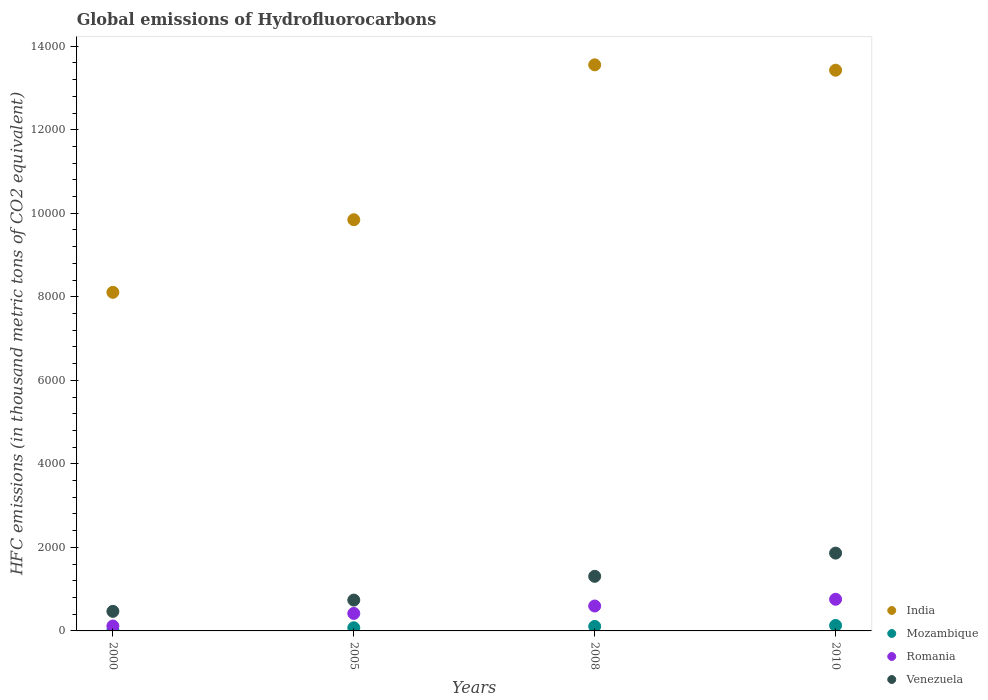Is the number of dotlines equal to the number of legend labels?
Make the answer very short. Yes. What is the global emissions of Hydrofluorocarbons in Romania in 2005?
Make the answer very short. 418.8. Across all years, what is the maximum global emissions of Hydrofluorocarbons in Venezuela?
Your answer should be compact. 1863. In which year was the global emissions of Hydrofluorocarbons in Romania minimum?
Provide a succinct answer. 2000. What is the total global emissions of Hydrofluorocarbons in Venezuela in the graph?
Provide a short and direct response. 4377. What is the difference between the global emissions of Hydrofluorocarbons in India in 2000 and that in 2008?
Give a very brief answer. -5446.5. What is the average global emissions of Hydrofluorocarbons in Romania per year?
Give a very brief answer. 472.85. In the year 2008, what is the difference between the global emissions of Hydrofluorocarbons in Venezuela and global emissions of Hydrofluorocarbons in Mozambique?
Make the answer very short. 1199.2. In how many years, is the global emissions of Hydrofluorocarbons in Venezuela greater than 2000 thousand metric tons?
Your answer should be very brief. 0. What is the ratio of the global emissions of Hydrofluorocarbons in Venezuela in 2005 to that in 2008?
Make the answer very short. 0.56. What is the difference between the highest and the second highest global emissions of Hydrofluorocarbons in India?
Provide a short and direct response. 128.7. What is the difference between the highest and the lowest global emissions of Hydrofluorocarbons in Venezuela?
Your response must be concise. 1394.5. In how many years, is the global emissions of Hydrofluorocarbons in Mozambique greater than the average global emissions of Hydrofluorocarbons in Mozambique taken over all years?
Give a very brief answer. 2. Is the sum of the global emissions of Hydrofluorocarbons in Mozambique in 2005 and 2008 greater than the maximum global emissions of Hydrofluorocarbons in Venezuela across all years?
Keep it short and to the point. No. Is it the case that in every year, the sum of the global emissions of Hydrofluorocarbons in Mozambique and global emissions of Hydrofluorocarbons in India  is greater than the sum of global emissions of Hydrofluorocarbons in Romania and global emissions of Hydrofluorocarbons in Venezuela?
Offer a terse response. Yes. Is the global emissions of Hydrofluorocarbons in India strictly greater than the global emissions of Hydrofluorocarbons in Romania over the years?
Give a very brief answer. Yes. How many dotlines are there?
Offer a very short reply. 4. What is the difference between two consecutive major ticks on the Y-axis?
Your answer should be compact. 2000. Does the graph contain grids?
Your answer should be very brief. No. Where does the legend appear in the graph?
Offer a terse response. Bottom right. How are the legend labels stacked?
Your answer should be very brief. Vertical. What is the title of the graph?
Your answer should be very brief. Global emissions of Hydrofluorocarbons. What is the label or title of the Y-axis?
Provide a short and direct response. HFC emissions (in thousand metric tons of CO2 equivalent). What is the HFC emissions (in thousand metric tons of CO2 equivalent) in India in 2000?
Your answer should be very brief. 8107.2. What is the HFC emissions (in thousand metric tons of CO2 equivalent) in Romania in 2000?
Keep it short and to the point. 118.2. What is the HFC emissions (in thousand metric tons of CO2 equivalent) of Venezuela in 2000?
Give a very brief answer. 468.5. What is the HFC emissions (in thousand metric tons of CO2 equivalent) in India in 2005?
Provide a succinct answer. 9845.2. What is the HFC emissions (in thousand metric tons of CO2 equivalent) of Mozambique in 2005?
Offer a terse response. 75.2. What is the HFC emissions (in thousand metric tons of CO2 equivalent) in Romania in 2005?
Offer a terse response. 418.8. What is the HFC emissions (in thousand metric tons of CO2 equivalent) in Venezuela in 2005?
Provide a succinct answer. 738.4. What is the HFC emissions (in thousand metric tons of CO2 equivalent) in India in 2008?
Keep it short and to the point. 1.36e+04. What is the HFC emissions (in thousand metric tons of CO2 equivalent) in Mozambique in 2008?
Your answer should be compact. 107.9. What is the HFC emissions (in thousand metric tons of CO2 equivalent) of Romania in 2008?
Provide a short and direct response. 596.4. What is the HFC emissions (in thousand metric tons of CO2 equivalent) in Venezuela in 2008?
Keep it short and to the point. 1307.1. What is the HFC emissions (in thousand metric tons of CO2 equivalent) of India in 2010?
Your response must be concise. 1.34e+04. What is the HFC emissions (in thousand metric tons of CO2 equivalent) in Mozambique in 2010?
Keep it short and to the point. 131. What is the HFC emissions (in thousand metric tons of CO2 equivalent) in Romania in 2010?
Offer a terse response. 758. What is the HFC emissions (in thousand metric tons of CO2 equivalent) of Venezuela in 2010?
Make the answer very short. 1863. Across all years, what is the maximum HFC emissions (in thousand metric tons of CO2 equivalent) of India?
Your response must be concise. 1.36e+04. Across all years, what is the maximum HFC emissions (in thousand metric tons of CO2 equivalent) in Mozambique?
Give a very brief answer. 131. Across all years, what is the maximum HFC emissions (in thousand metric tons of CO2 equivalent) in Romania?
Your response must be concise. 758. Across all years, what is the maximum HFC emissions (in thousand metric tons of CO2 equivalent) in Venezuela?
Make the answer very short. 1863. Across all years, what is the minimum HFC emissions (in thousand metric tons of CO2 equivalent) of India?
Keep it short and to the point. 8107.2. Across all years, what is the minimum HFC emissions (in thousand metric tons of CO2 equivalent) of Mozambique?
Offer a very short reply. 18.8. Across all years, what is the minimum HFC emissions (in thousand metric tons of CO2 equivalent) in Romania?
Offer a terse response. 118.2. Across all years, what is the minimum HFC emissions (in thousand metric tons of CO2 equivalent) of Venezuela?
Provide a short and direct response. 468.5. What is the total HFC emissions (in thousand metric tons of CO2 equivalent) in India in the graph?
Offer a terse response. 4.49e+04. What is the total HFC emissions (in thousand metric tons of CO2 equivalent) of Mozambique in the graph?
Offer a terse response. 332.9. What is the total HFC emissions (in thousand metric tons of CO2 equivalent) of Romania in the graph?
Your answer should be very brief. 1891.4. What is the total HFC emissions (in thousand metric tons of CO2 equivalent) of Venezuela in the graph?
Provide a short and direct response. 4377. What is the difference between the HFC emissions (in thousand metric tons of CO2 equivalent) in India in 2000 and that in 2005?
Provide a short and direct response. -1738. What is the difference between the HFC emissions (in thousand metric tons of CO2 equivalent) of Mozambique in 2000 and that in 2005?
Provide a succinct answer. -56.4. What is the difference between the HFC emissions (in thousand metric tons of CO2 equivalent) in Romania in 2000 and that in 2005?
Provide a succinct answer. -300.6. What is the difference between the HFC emissions (in thousand metric tons of CO2 equivalent) in Venezuela in 2000 and that in 2005?
Your response must be concise. -269.9. What is the difference between the HFC emissions (in thousand metric tons of CO2 equivalent) in India in 2000 and that in 2008?
Ensure brevity in your answer.  -5446.5. What is the difference between the HFC emissions (in thousand metric tons of CO2 equivalent) in Mozambique in 2000 and that in 2008?
Make the answer very short. -89.1. What is the difference between the HFC emissions (in thousand metric tons of CO2 equivalent) of Romania in 2000 and that in 2008?
Offer a very short reply. -478.2. What is the difference between the HFC emissions (in thousand metric tons of CO2 equivalent) in Venezuela in 2000 and that in 2008?
Keep it short and to the point. -838.6. What is the difference between the HFC emissions (in thousand metric tons of CO2 equivalent) of India in 2000 and that in 2010?
Your answer should be very brief. -5317.8. What is the difference between the HFC emissions (in thousand metric tons of CO2 equivalent) of Mozambique in 2000 and that in 2010?
Provide a short and direct response. -112.2. What is the difference between the HFC emissions (in thousand metric tons of CO2 equivalent) in Romania in 2000 and that in 2010?
Offer a very short reply. -639.8. What is the difference between the HFC emissions (in thousand metric tons of CO2 equivalent) of Venezuela in 2000 and that in 2010?
Your answer should be very brief. -1394.5. What is the difference between the HFC emissions (in thousand metric tons of CO2 equivalent) in India in 2005 and that in 2008?
Your answer should be compact. -3708.5. What is the difference between the HFC emissions (in thousand metric tons of CO2 equivalent) in Mozambique in 2005 and that in 2008?
Provide a succinct answer. -32.7. What is the difference between the HFC emissions (in thousand metric tons of CO2 equivalent) of Romania in 2005 and that in 2008?
Provide a short and direct response. -177.6. What is the difference between the HFC emissions (in thousand metric tons of CO2 equivalent) in Venezuela in 2005 and that in 2008?
Give a very brief answer. -568.7. What is the difference between the HFC emissions (in thousand metric tons of CO2 equivalent) in India in 2005 and that in 2010?
Offer a terse response. -3579.8. What is the difference between the HFC emissions (in thousand metric tons of CO2 equivalent) of Mozambique in 2005 and that in 2010?
Offer a very short reply. -55.8. What is the difference between the HFC emissions (in thousand metric tons of CO2 equivalent) of Romania in 2005 and that in 2010?
Make the answer very short. -339.2. What is the difference between the HFC emissions (in thousand metric tons of CO2 equivalent) in Venezuela in 2005 and that in 2010?
Give a very brief answer. -1124.6. What is the difference between the HFC emissions (in thousand metric tons of CO2 equivalent) in India in 2008 and that in 2010?
Your response must be concise. 128.7. What is the difference between the HFC emissions (in thousand metric tons of CO2 equivalent) in Mozambique in 2008 and that in 2010?
Provide a succinct answer. -23.1. What is the difference between the HFC emissions (in thousand metric tons of CO2 equivalent) in Romania in 2008 and that in 2010?
Your response must be concise. -161.6. What is the difference between the HFC emissions (in thousand metric tons of CO2 equivalent) of Venezuela in 2008 and that in 2010?
Your response must be concise. -555.9. What is the difference between the HFC emissions (in thousand metric tons of CO2 equivalent) in India in 2000 and the HFC emissions (in thousand metric tons of CO2 equivalent) in Mozambique in 2005?
Make the answer very short. 8032. What is the difference between the HFC emissions (in thousand metric tons of CO2 equivalent) in India in 2000 and the HFC emissions (in thousand metric tons of CO2 equivalent) in Romania in 2005?
Keep it short and to the point. 7688.4. What is the difference between the HFC emissions (in thousand metric tons of CO2 equivalent) in India in 2000 and the HFC emissions (in thousand metric tons of CO2 equivalent) in Venezuela in 2005?
Keep it short and to the point. 7368.8. What is the difference between the HFC emissions (in thousand metric tons of CO2 equivalent) in Mozambique in 2000 and the HFC emissions (in thousand metric tons of CO2 equivalent) in Romania in 2005?
Provide a short and direct response. -400. What is the difference between the HFC emissions (in thousand metric tons of CO2 equivalent) in Mozambique in 2000 and the HFC emissions (in thousand metric tons of CO2 equivalent) in Venezuela in 2005?
Make the answer very short. -719.6. What is the difference between the HFC emissions (in thousand metric tons of CO2 equivalent) in Romania in 2000 and the HFC emissions (in thousand metric tons of CO2 equivalent) in Venezuela in 2005?
Your response must be concise. -620.2. What is the difference between the HFC emissions (in thousand metric tons of CO2 equivalent) of India in 2000 and the HFC emissions (in thousand metric tons of CO2 equivalent) of Mozambique in 2008?
Provide a short and direct response. 7999.3. What is the difference between the HFC emissions (in thousand metric tons of CO2 equivalent) in India in 2000 and the HFC emissions (in thousand metric tons of CO2 equivalent) in Romania in 2008?
Your answer should be compact. 7510.8. What is the difference between the HFC emissions (in thousand metric tons of CO2 equivalent) of India in 2000 and the HFC emissions (in thousand metric tons of CO2 equivalent) of Venezuela in 2008?
Provide a short and direct response. 6800.1. What is the difference between the HFC emissions (in thousand metric tons of CO2 equivalent) in Mozambique in 2000 and the HFC emissions (in thousand metric tons of CO2 equivalent) in Romania in 2008?
Make the answer very short. -577.6. What is the difference between the HFC emissions (in thousand metric tons of CO2 equivalent) in Mozambique in 2000 and the HFC emissions (in thousand metric tons of CO2 equivalent) in Venezuela in 2008?
Provide a succinct answer. -1288.3. What is the difference between the HFC emissions (in thousand metric tons of CO2 equivalent) in Romania in 2000 and the HFC emissions (in thousand metric tons of CO2 equivalent) in Venezuela in 2008?
Your answer should be very brief. -1188.9. What is the difference between the HFC emissions (in thousand metric tons of CO2 equivalent) of India in 2000 and the HFC emissions (in thousand metric tons of CO2 equivalent) of Mozambique in 2010?
Keep it short and to the point. 7976.2. What is the difference between the HFC emissions (in thousand metric tons of CO2 equivalent) in India in 2000 and the HFC emissions (in thousand metric tons of CO2 equivalent) in Romania in 2010?
Offer a very short reply. 7349.2. What is the difference between the HFC emissions (in thousand metric tons of CO2 equivalent) in India in 2000 and the HFC emissions (in thousand metric tons of CO2 equivalent) in Venezuela in 2010?
Provide a succinct answer. 6244.2. What is the difference between the HFC emissions (in thousand metric tons of CO2 equivalent) of Mozambique in 2000 and the HFC emissions (in thousand metric tons of CO2 equivalent) of Romania in 2010?
Provide a succinct answer. -739.2. What is the difference between the HFC emissions (in thousand metric tons of CO2 equivalent) of Mozambique in 2000 and the HFC emissions (in thousand metric tons of CO2 equivalent) of Venezuela in 2010?
Make the answer very short. -1844.2. What is the difference between the HFC emissions (in thousand metric tons of CO2 equivalent) of Romania in 2000 and the HFC emissions (in thousand metric tons of CO2 equivalent) of Venezuela in 2010?
Provide a succinct answer. -1744.8. What is the difference between the HFC emissions (in thousand metric tons of CO2 equivalent) in India in 2005 and the HFC emissions (in thousand metric tons of CO2 equivalent) in Mozambique in 2008?
Provide a succinct answer. 9737.3. What is the difference between the HFC emissions (in thousand metric tons of CO2 equivalent) of India in 2005 and the HFC emissions (in thousand metric tons of CO2 equivalent) of Romania in 2008?
Give a very brief answer. 9248.8. What is the difference between the HFC emissions (in thousand metric tons of CO2 equivalent) in India in 2005 and the HFC emissions (in thousand metric tons of CO2 equivalent) in Venezuela in 2008?
Offer a terse response. 8538.1. What is the difference between the HFC emissions (in thousand metric tons of CO2 equivalent) of Mozambique in 2005 and the HFC emissions (in thousand metric tons of CO2 equivalent) of Romania in 2008?
Your answer should be very brief. -521.2. What is the difference between the HFC emissions (in thousand metric tons of CO2 equivalent) of Mozambique in 2005 and the HFC emissions (in thousand metric tons of CO2 equivalent) of Venezuela in 2008?
Provide a succinct answer. -1231.9. What is the difference between the HFC emissions (in thousand metric tons of CO2 equivalent) of Romania in 2005 and the HFC emissions (in thousand metric tons of CO2 equivalent) of Venezuela in 2008?
Keep it short and to the point. -888.3. What is the difference between the HFC emissions (in thousand metric tons of CO2 equivalent) of India in 2005 and the HFC emissions (in thousand metric tons of CO2 equivalent) of Mozambique in 2010?
Your answer should be compact. 9714.2. What is the difference between the HFC emissions (in thousand metric tons of CO2 equivalent) in India in 2005 and the HFC emissions (in thousand metric tons of CO2 equivalent) in Romania in 2010?
Provide a short and direct response. 9087.2. What is the difference between the HFC emissions (in thousand metric tons of CO2 equivalent) of India in 2005 and the HFC emissions (in thousand metric tons of CO2 equivalent) of Venezuela in 2010?
Make the answer very short. 7982.2. What is the difference between the HFC emissions (in thousand metric tons of CO2 equivalent) of Mozambique in 2005 and the HFC emissions (in thousand metric tons of CO2 equivalent) of Romania in 2010?
Keep it short and to the point. -682.8. What is the difference between the HFC emissions (in thousand metric tons of CO2 equivalent) in Mozambique in 2005 and the HFC emissions (in thousand metric tons of CO2 equivalent) in Venezuela in 2010?
Give a very brief answer. -1787.8. What is the difference between the HFC emissions (in thousand metric tons of CO2 equivalent) of Romania in 2005 and the HFC emissions (in thousand metric tons of CO2 equivalent) of Venezuela in 2010?
Provide a succinct answer. -1444.2. What is the difference between the HFC emissions (in thousand metric tons of CO2 equivalent) in India in 2008 and the HFC emissions (in thousand metric tons of CO2 equivalent) in Mozambique in 2010?
Keep it short and to the point. 1.34e+04. What is the difference between the HFC emissions (in thousand metric tons of CO2 equivalent) in India in 2008 and the HFC emissions (in thousand metric tons of CO2 equivalent) in Romania in 2010?
Your answer should be compact. 1.28e+04. What is the difference between the HFC emissions (in thousand metric tons of CO2 equivalent) in India in 2008 and the HFC emissions (in thousand metric tons of CO2 equivalent) in Venezuela in 2010?
Ensure brevity in your answer.  1.17e+04. What is the difference between the HFC emissions (in thousand metric tons of CO2 equivalent) in Mozambique in 2008 and the HFC emissions (in thousand metric tons of CO2 equivalent) in Romania in 2010?
Offer a very short reply. -650.1. What is the difference between the HFC emissions (in thousand metric tons of CO2 equivalent) in Mozambique in 2008 and the HFC emissions (in thousand metric tons of CO2 equivalent) in Venezuela in 2010?
Offer a very short reply. -1755.1. What is the difference between the HFC emissions (in thousand metric tons of CO2 equivalent) in Romania in 2008 and the HFC emissions (in thousand metric tons of CO2 equivalent) in Venezuela in 2010?
Your answer should be very brief. -1266.6. What is the average HFC emissions (in thousand metric tons of CO2 equivalent) of India per year?
Give a very brief answer. 1.12e+04. What is the average HFC emissions (in thousand metric tons of CO2 equivalent) in Mozambique per year?
Give a very brief answer. 83.22. What is the average HFC emissions (in thousand metric tons of CO2 equivalent) in Romania per year?
Provide a short and direct response. 472.85. What is the average HFC emissions (in thousand metric tons of CO2 equivalent) in Venezuela per year?
Provide a short and direct response. 1094.25. In the year 2000, what is the difference between the HFC emissions (in thousand metric tons of CO2 equivalent) in India and HFC emissions (in thousand metric tons of CO2 equivalent) in Mozambique?
Offer a terse response. 8088.4. In the year 2000, what is the difference between the HFC emissions (in thousand metric tons of CO2 equivalent) in India and HFC emissions (in thousand metric tons of CO2 equivalent) in Romania?
Your answer should be compact. 7989. In the year 2000, what is the difference between the HFC emissions (in thousand metric tons of CO2 equivalent) in India and HFC emissions (in thousand metric tons of CO2 equivalent) in Venezuela?
Give a very brief answer. 7638.7. In the year 2000, what is the difference between the HFC emissions (in thousand metric tons of CO2 equivalent) of Mozambique and HFC emissions (in thousand metric tons of CO2 equivalent) of Romania?
Provide a short and direct response. -99.4. In the year 2000, what is the difference between the HFC emissions (in thousand metric tons of CO2 equivalent) in Mozambique and HFC emissions (in thousand metric tons of CO2 equivalent) in Venezuela?
Your response must be concise. -449.7. In the year 2000, what is the difference between the HFC emissions (in thousand metric tons of CO2 equivalent) of Romania and HFC emissions (in thousand metric tons of CO2 equivalent) of Venezuela?
Ensure brevity in your answer.  -350.3. In the year 2005, what is the difference between the HFC emissions (in thousand metric tons of CO2 equivalent) of India and HFC emissions (in thousand metric tons of CO2 equivalent) of Mozambique?
Your answer should be very brief. 9770. In the year 2005, what is the difference between the HFC emissions (in thousand metric tons of CO2 equivalent) in India and HFC emissions (in thousand metric tons of CO2 equivalent) in Romania?
Make the answer very short. 9426.4. In the year 2005, what is the difference between the HFC emissions (in thousand metric tons of CO2 equivalent) in India and HFC emissions (in thousand metric tons of CO2 equivalent) in Venezuela?
Provide a succinct answer. 9106.8. In the year 2005, what is the difference between the HFC emissions (in thousand metric tons of CO2 equivalent) of Mozambique and HFC emissions (in thousand metric tons of CO2 equivalent) of Romania?
Offer a terse response. -343.6. In the year 2005, what is the difference between the HFC emissions (in thousand metric tons of CO2 equivalent) of Mozambique and HFC emissions (in thousand metric tons of CO2 equivalent) of Venezuela?
Provide a short and direct response. -663.2. In the year 2005, what is the difference between the HFC emissions (in thousand metric tons of CO2 equivalent) of Romania and HFC emissions (in thousand metric tons of CO2 equivalent) of Venezuela?
Offer a very short reply. -319.6. In the year 2008, what is the difference between the HFC emissions (in thousand metric tons of CO2 equivalent) of India and HFC emissions (in thousand metric tons of CO2 equivalent) of Mozambique?
Offer a terse response. 1.34e+04. In the year 2008, what is the difference between the HFC emissions (in thousand metric tons of CO2 equivalent) of India and HFC emissions (in thousand metric tons of CO2 equivalent) of Romania?
Ensure brevity in your answer.  1.30e+04. In the year 2008, what is the difference between the HFC emissions (in thousand metric tons of CO2 equivalent) in India and HFC emissions (in thousand metric tons of CO2 equivalent) in Venezuela?
Make the answer very short. 1.22e+04. In the year 2008, what is the difference between the HFC emissions (in thousand metric tons of CO2 equivalent) of Mozambique and HFC emissions (in thousand metric tons of CO2 equivalent) of Romania?
Offer a terse response. -488.5. In the year 2008, what is the difference between the HFC emissions (in thousand metric tons of CO2 equivalent) of Mozambique and HFC emissions (in thousand metric tons of CO2 equivalent) of Venezuela?
Offer a very short reply. -1199.2. In the year 2008, what is the difference between the HFC emissions (in thousand metric tons of CO2 equivalent) in Romania and HFC emissions (in thousand metric tons of CO2 equivalent) in Venezuela?
Ensure brevity in your answer.  -710.7. In the year 2010, what is the difference between the HFC emissions (in thousand metric tons of CO2 equivalent) in India and HFC emissions (in thousand metric tons of CO2 equivalent) in Mozambique?
Provide a short and direct response. 1.33e+04. In the year 2010, what is the difference between the HFC emissions (in thousand metric tons of CO2 equivalent) of India and HFC emissions (in thousand metric tons of CO2 equivalent) of Romania?
Your response must be concise. 1.27e+04. In the year 2010, what is the difference between the HFC emissions (in thousand metric tons of CO2 equivalent) in India and HFC emissions (in thousand metric tons of CO2 equivalent) in Venezuela?
Your response must be concise. 1.16e+04. In the year 2010, what is the difference between the HFC emissions (in thousand metric tons of CO2 equivalent) in Mozambique and HFC emissions (in thousand metric tons of CO2 equivalent) in Romania?
Your answer should be compact. -627. In the year 2010, what is the difference between the HFC emissions (in thousand metric tons of CO2 equivalent) of Mozambique and HFC emissions (in thousand metric tons of CO2 equivalent) of Venezuela?
Ensure brevity in your answer.  -1732. In the year 2010, what is the difference between the HFC emissions (in thousand metric tons of CO2 equivalent) of Romania and HFC emissions (in thousand metric tons of CO2 equivalent) of Venezuela?
Your answer should be compact. -1105. What is the ratio of the HFC emissions (in thousand metric tons of CO2 equivalent) of India in 2000 to that in 2005?
Offer a terse response. 0.82. What is the ratio of the HFC emissions (in thousand metric tons of CO2 equivalent) in Romania in 2000 to that in 2005?
Make the answer very short. 0.28. What is the ratio of the HFC emissions (in thousand metric tons of CO2 equivalent) of Venezuela in 2000 to that in 2005?
Offer a terse response. 0.63. What is the ratio of the HFC emissions (in thousand metric tons of CO2 equivalent) in India in 2000 to that in 2008?
Your answer should be compact. 0.6. What is the ratio of the HFC emissions (in thousand metric tons of CO2 equivalent) of Mozambique in 2000 to that in 2008?
Keep it short and to the point. 0.17. What is the ratio of the HFC emissions (in thousand metric tons of CO2 equivalent) of Romania in 2000 to that in 2008?
Provide a short and direct response. 0.2. What is the ratio of the HFC emissions (in thousand metric tons of CO2 equivalent) of Venezuela in 2000 to that in 2008?
Offer a very short reply. 0.36. What is the ratio of the HFC emissions (in thousand metric tons of CO2 equivalent) of India in 2000 to that in 2010?
Make the answer very short. 0.6. What is the ratio of the HFC emissions (in thousand metric tons of CO2 equivalent) of Mozambique in 2000 to that in 2010?
Give a very brief answer. 0.14. What is the ratio of the HFC emissions (in thousand metric tons of CO2 equivalent) of Romania in 2000 to that in 2010?
Provide a short and direct response. 0.16. What is the ratio of the HFC emissions (in thousand metric tons of CO2 equivalent) of Venezuela in 2000 to that in 2010?
Offer a very short reply. 0.25. What is the ratio of the HFC emissions (in thousand metric tons of CO2 equivalent) in India in 2005 to that in 2008?
Your response must be concise. 0.73. What is the ratio of the HFC emissions (in thousand metric tons of CO2 equivalent) in Mozambique in 2005 to that in 2008?
Your answer should be very brief. 0.7. What is the ratio of the HFC emissions (in thousand metric tons of CO2 equivalent) of Romania in 2005 to that in 2008?
Offer a very short reply. 0.7. What is the ratio of the HFC emissions (in thousand metric tons of CO2 equivalent) in Venezuela in 2005 to that in 2008?
Make the answer very short. 0.56. What is the ratio of the HFC emissions (in thousand metric tons of CO2 equivalent) in India in 2005 to that in 2010?
Your answer should be very brief. 0.73. What is the ratio of the HFC emissions (in thousand metric tons of CO2 equivalent) in Mozambique in 2005 to that in 2010?
Give a very brief answer. 0.57. What is the ratio of the HFC emissions (in thousand metric tons of CO2 equivalent) in Romania in 2005 to that in 2010?
Give a very brief answer. 0.55. What is the ratio of the HFC emissions (in thousand metric tons of CO2 equivalent) of Venezuela in 2005 to that in 2010?
Your answer should be compact. 0.4. What is the ratio of the HFC emissions (in thousand metric tons of CO2 equivalent) in India in 2008 to that in 2010?
Offer a terse response. 1.01. What is the ratio of the HFC emissions (in thousand metric tons of CO2 equivalent) in Mozambique in 2008 to that in 2010?
Provide a succinct answer. 0.82. What is the ratio of the HFC emissions (in thousand metric tons of CO2 equivalent) in Romania in 2008 to that in 2010?
Make the answer very short. 0.79. What is the ratio of the HFC emissions (in thousand metric tons of CO2 equivalent) in Venezuela in 2008 to that in 2010?
Offer a terse response. 0.7. What is the difference between the highest and the second highest HFC emissions (in thousand metric tons of CO2 equivalent) in India?
Ensure brevity in your answer.  128.7. What is the difference between the highest and the second highest HFC emissions (in thousand metric tons of CO2 equivalent) of Mozambique?
Your answer should be compact. 23.1. What is the difference between the highest and the second highest HFC emissions (in thousand metric tons of CO2 equivalent) of Romania?
Your response must be concise. 161.6. What is the difference between the highest and the second highest HFC emissions (in thousand metric tons of CO2 equivalent) in Venezuela?
Give a very brief answer. 555.9. What is the difference between the highest and the lowest HFC emissions (in thousand metric tons of CO2 equivalent) of India?
Offer a very short reply. 5446.5. What is the difference between the highest and the lowest HFC emissions (in thousand metric tons of CO2 equivalent) in Mozambique?
Provide a short and direct response. 112.2. What is the difference between the highest and the lowest HFC emissions (in thousand metric tons of CO2 equivalent) in Romania?
Your answer should be compact. 639.8. What is the difference between the highest and the lowest HFC emissions (in thousand metric tons of CO2 equivalent) in Venezuela?
Your answer should be compact. 1394.5. 